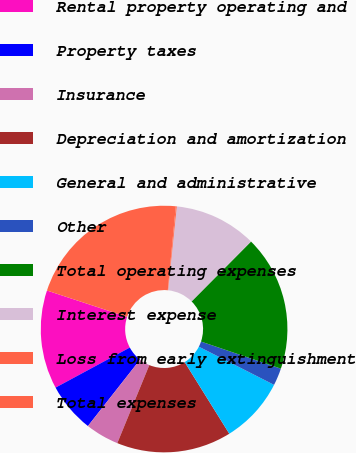Convert chart. <chart><loc_0><loc_0><loc_500><loc_500><pie_chart><fcel>Rental property operating and<fcel>Property taxes<fcel>Insurance<fcel>Depreciation and amortization<fcel>General and administrative<fcel>Other<fcel>Total operating expenses<fcel>Interest expense<fcel>Loss from early extinguishment<fcel>Total expenses<nl><fcel>12.93%<fcel>6.53%<fcel>4.4%<fcel>15.06%<fcel>8.66%<fcel>2.27%<fcel>17.76%<fcel>10.8%<fcel>0.13%<fcel>21.46%<nl></chart> 